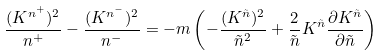Convert formula to latex. <formula><loc_0><loc_0><loc_500><loc_500>\frac { ( K ^ { n ^ { + } } ) ^ { 2 } } { n ^ { + } } - \frac { ( K ^ { n ^ { - } } ) ^ { 2 } } { n ^ { - } } = - m \left ( - \frac { ( K ^ { \tilde { n } } ) ^ { 2 } } { \tilde { n } ^ { 2 } } + \frac { 2 } { \tilde { n } } K ^ { \tilde { n } } \frac { \partial K ^ { \tilde { n } } } { \partial \tilde { n } } \right )</formula> 